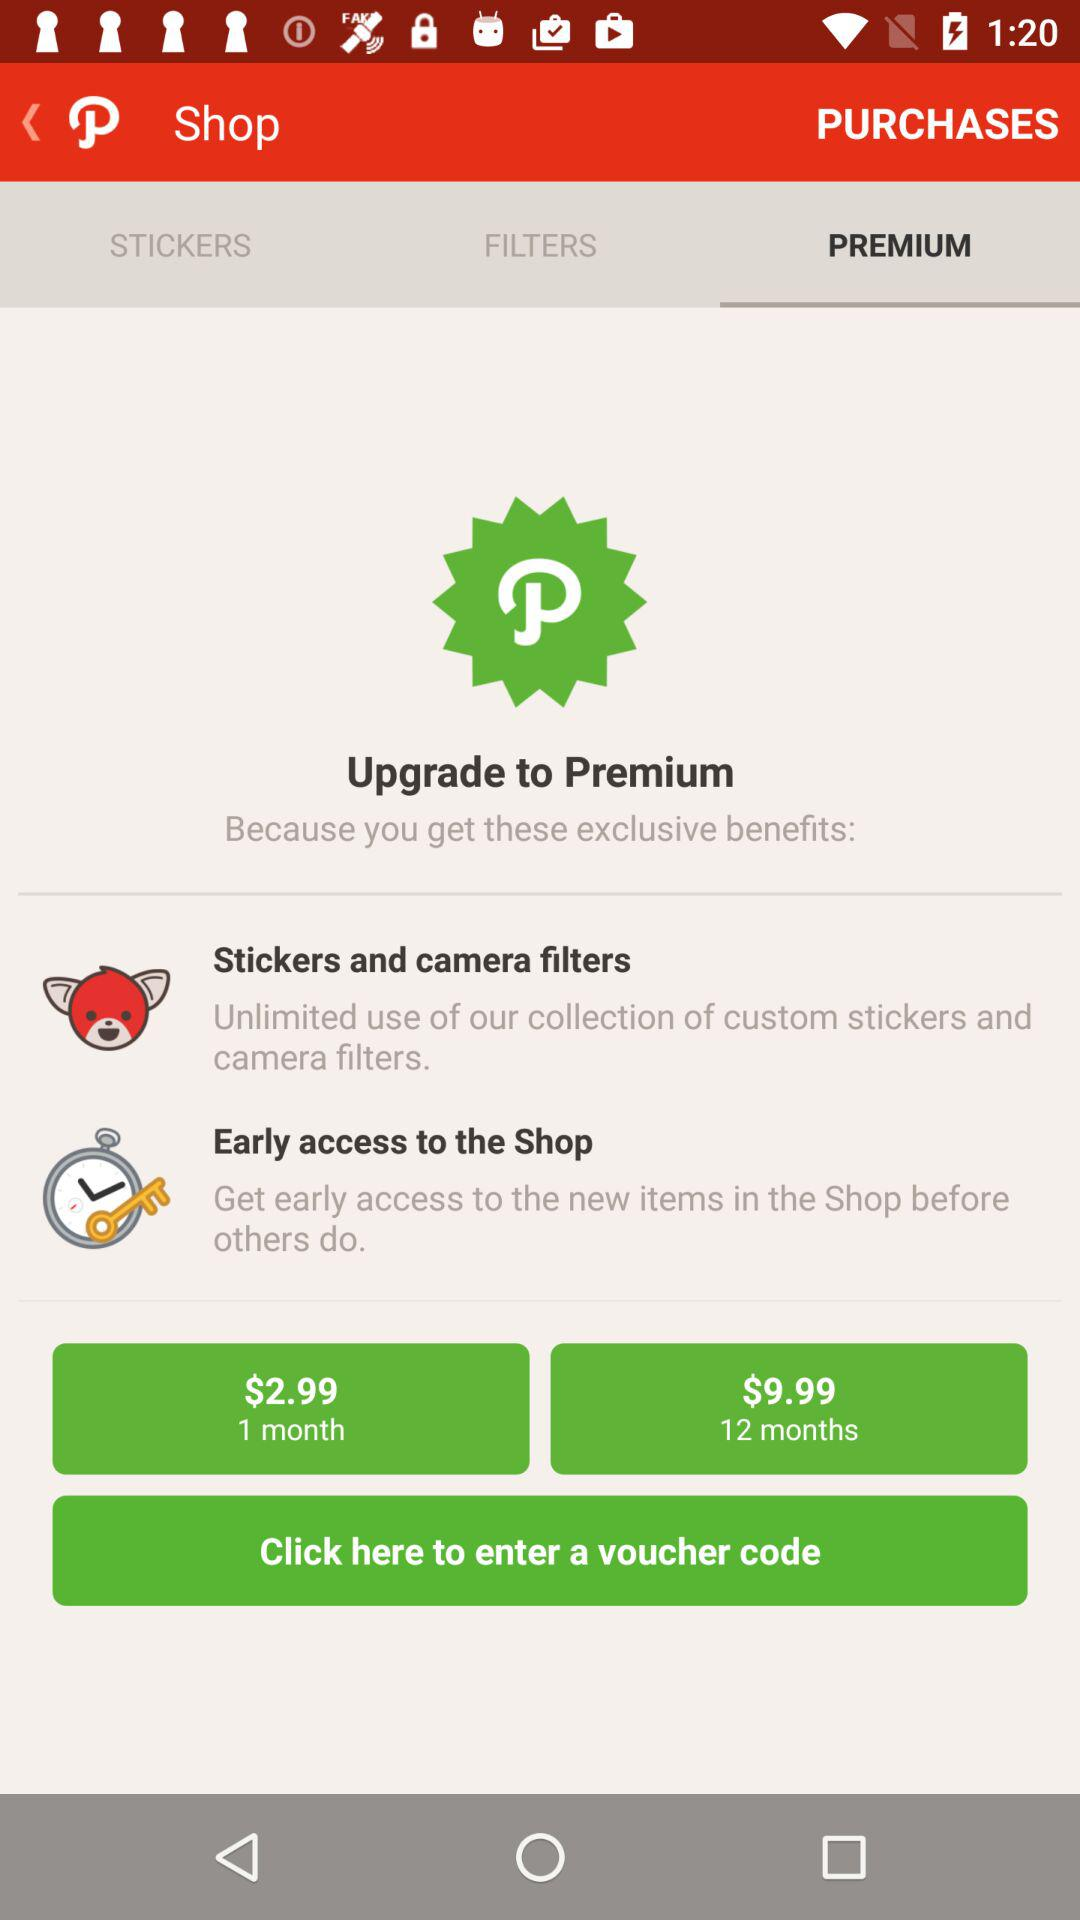What is the price for 12 months? The price for 12 months is $9.99. 